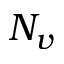<formula> <loc_0><loc_0><loc_500><loc_500>N _ { v }</formula> 